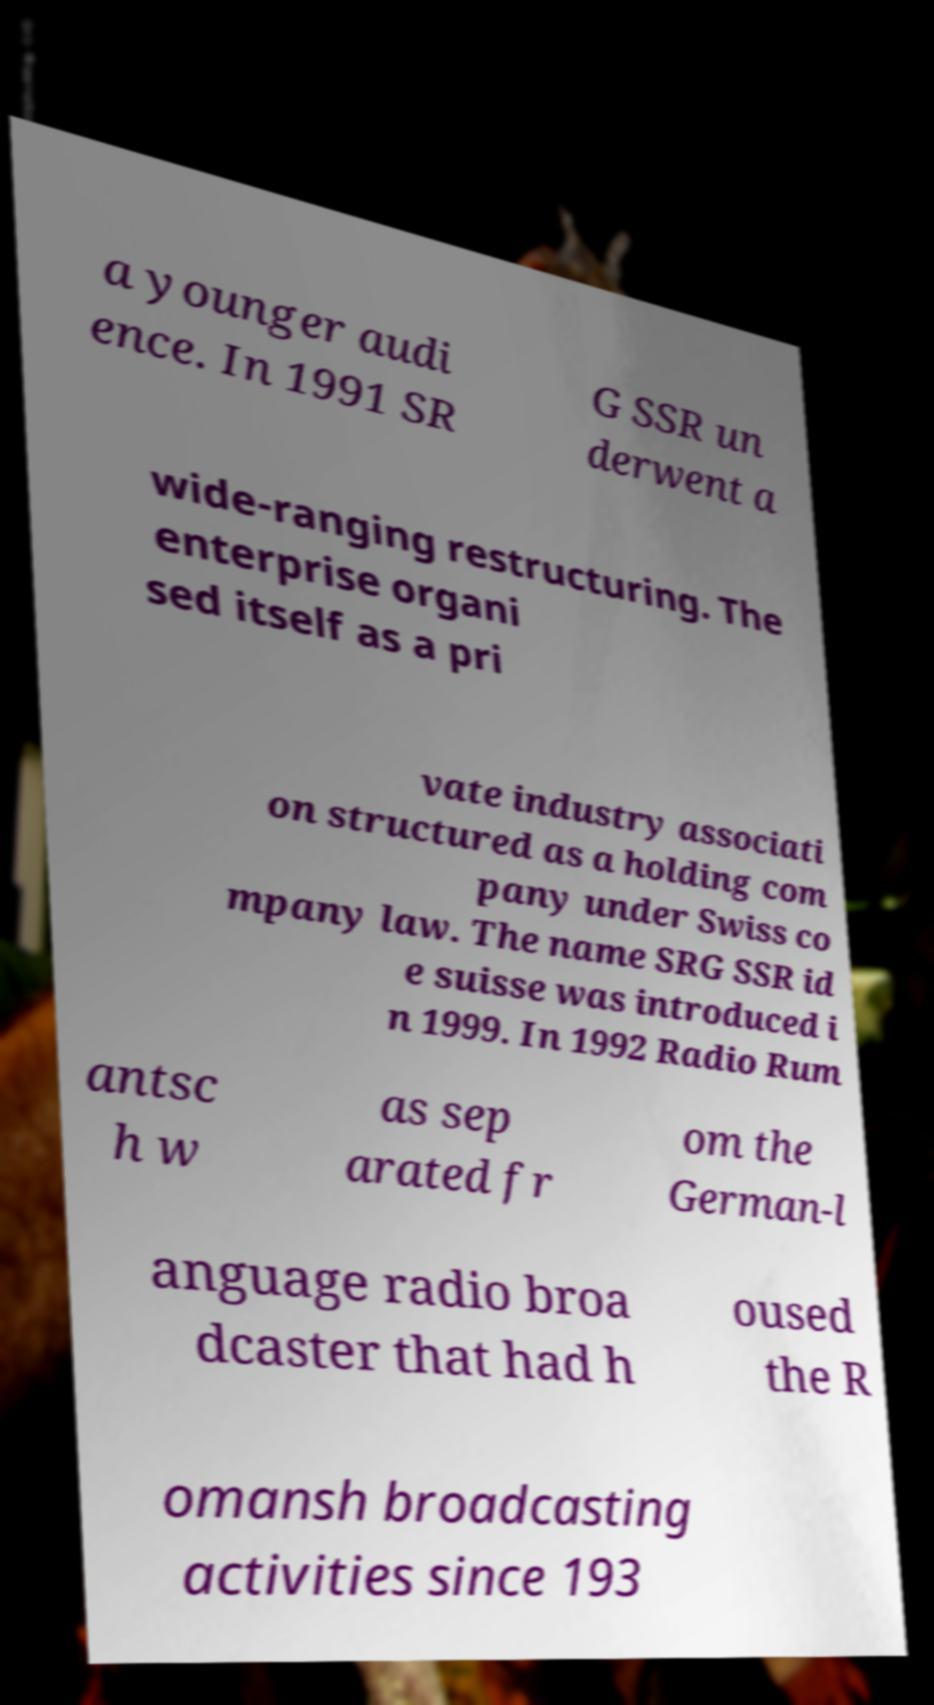Can you accurately transcribe the text from the provided image for me? a younger audi ence. In 1991 SR G SSR un derwent a wide-ranging restructuring. The enterprise organi sed itself as a pri vate industry associati on structured as a holding com pany under Swiss co mpany law. The name SRG SSR id e suisse was introduced i n 1999. In 1992 Radio Rum antsc h w as sep arated fr om the German-l anguage radio broa dcaster that had h oused the R omansh broadcasting activities since 193 